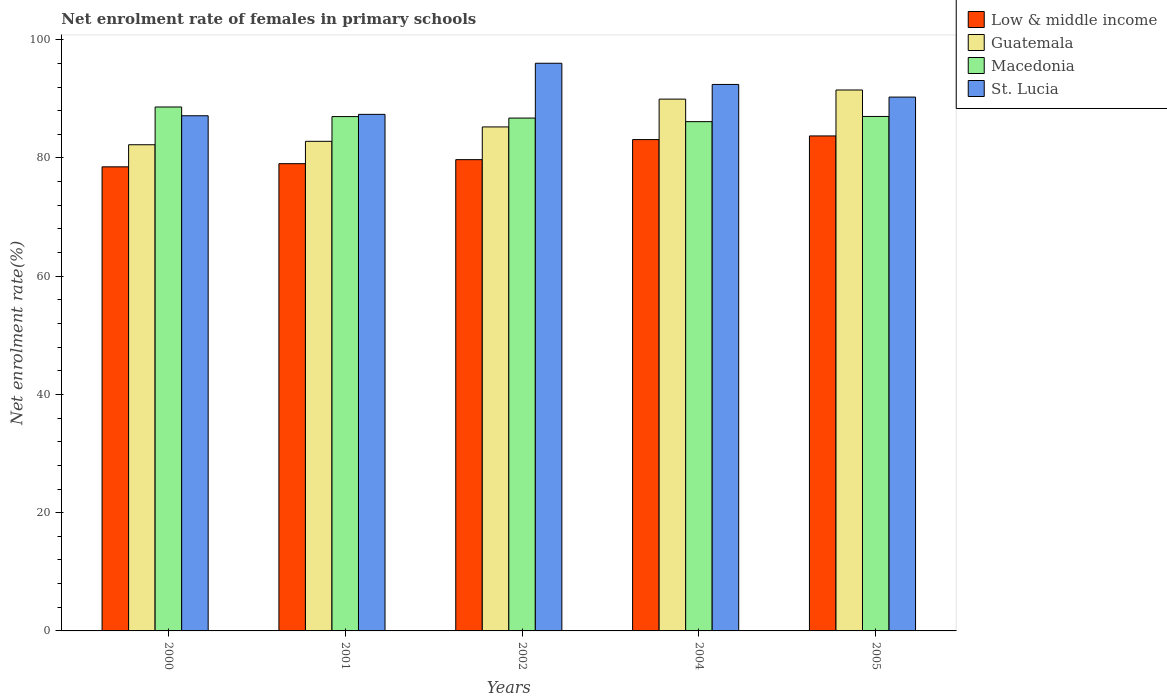How many different coloured bars are there?
Offer a very short reply. 4. How many groups of bars are there?
Your response must be concise. 5. Are the number of bars per tick equal to the number of legend labels?
Offer a terse response. Yes. How many bars are there on the 3rd tick from the left?
Offer a very short reply. 4. In how many cases, is the number of bars for a given year not equal to the number of legend labels?
Provide a short and direct response. 0. What is the net enrolment rate of females in primary schools in Guatemala in 2001?
Your response must be concise. 82.82. Across all years, what is the maximum net enrolment rate of females in primary schools in Guatemala?
Give a very brief answer. 91.5. Across all years, what is the minimum net enrolment rate of females in primary schools in Low & middle income?
Make the answer very short. 78.51. In which year was the net enrolment rate of females in primary schools in St. Lucia maximum?
Your answer should be compact. 2002. What is the total net enrolment rate of females in primary schools in Guatemala in the graph?
Your answer should be very brief. 431.78. What is the difference between the net enrolment rate of females in primary schools in Guatemala in 2000 and that in 2001?
Provide a succinct answer. -0.58. What is the difference between the net enrolment rate of females in primary schools in Low & middle income in 2005 and the net enrolment rate of females in primary schools in St. Lucia in 2004?
Ensure brevity in your answer.  -8.71. What is the average net enrolment rate of females in primary schools in St. Lucia per year?
Offer a terse response. 90.66. In the year 2005, what is the difference between the net enrolment rate of females in primary schools in Guatemala and net enrolment rate of females in primary schools in Low & middle income?
Keep it short and to the point. 7.77. What is the ratio of the net enrolment rate of females in primary schools in Macedonia in 2001 to that in 2005?
Your answer should be compact. 1. Is the net enrolment rate of females in primary schools in Low & middle income in 2002 less than that in 2004?
Give a very brief answer. Yes. What is the difference between the highest and the second highest net enrolment rate of females in primary schools in Low & middle income?
Make the answer very short. 0.62. What is the difference between the highest and the lowest net enrolment rate of females in primary schools in Low & middle income?
Your response must be concise. 5.23. In how many years, is the net enrolment rate of females in primary schools in St. Lucia greater than the average net enrolment rate of females in primary schools in St. Lucia taken over all years?
Your response must be concise. 2. Is the sum of the net enrolment rate of females in primary schools in Guatemala in 2002 and 2004 greater than the maximum net enrolment rate of females in primary schools in St. Lucia across all years?
Make the answer very short. Yes. Is it the case that in every year, the sum of the net enrolment rate of females in primary schools in Guatemala and net enrolment rate of females in primary schools in Macedonia is greater than the sum of net enrolment rate of females in primary schools in Low & middle income and net enrolment rate of females in primary schools in St. Lucia?
Keep it short and to the point. Yes. What does the 3rd bar from the left in 2002 represents?
Give a very brief answer. Macedonia. What does the 2nd bar from the right in 2002 represents?
Offer a terse response. Macedonia. Is it the case that in every year, the sum of the net enrolment rate of females in primary schools in Guatemala and net enrolment rate of females in primary schools in St. Lucia is greater than the net enrolment rate of females in primary schools in Macedonia?
Your answer should be compact. Yes. How many bars are there?
Keep it short and to the point. 20. What is the difference between two consecutive major ticks on the Y-axis?
Your answer should be very brief. 20. Are the values on the major ticks of Y-axis written in scientific E-notation?
Provide a short and direct response. No. Does the graph contain any zero values?
Make the answer very short. No. Does the graph contain grids?
Your answer should be compact. No. How are the legend labels stacked?
Offer a terse response. Vertical. What is the title of the graph?
Offer a very short reply. Net enrolment rate of females in primary schools. What is the label or title of the X-axis?
Keep it short and to the point. Years. What is the label or title of the Y-axis?
Ensure brevity in your answer.  Net enrolment rate(%). What is the Net enrolment rate(%) of Low & middle income in 2000?
Give a very brief answer. 78.51. What is the Net enrolment rate(%) of Guatemala in 2000?
Provide a short and direct response. 82.24. What is the Net enrolment rate(%) of Macedonia in 2000?
Provide a short and direct response. 88.63. What is the Net enrolment rate(%) of St. Lucia in 2000?
Ensure brevity in your answer.  87.15. What is the Net enrolment rate(%) of Low & middle income in 2001?
Offer a very short reply. 79.04. What is the Net enrolment rate(%) in Guatemala in 2001?
Ensure brevity in your answer.  82.82. What is the Net enrolment rate(%) in Macedonia in 2001?
Ensure brevity in your answer.  87.01. What is the Net enrolment rate(%) of St. Lucia in 2001?
Your response must be concise. 87.38. What is the Net enrolment rate(%) in Low & middle income in 2002?
Your response must be concise. 79.72. What is the Net enrolment rate(%) of Guatemala in 2002?
Give a very brief answer. 85.26. What is the Net enrolment rate(%) of Macedonia in 2002?
Make the answer very short. 86.75. What is the Net enrolment rate(%) of St. Lucia in 2002?
Provide a succinct answer. 96.03. What is the Net enrolment rate(%) in Low & middle income in 2004?
Give a very brief answer. 83.11. What is the Net enrolment rate(%) of Guatemala in 2004?
Offer a terse response. 89.96. What is the Net enrolment rate(%) in Macedonia in 2004?
Provide a succinct answer. 86.15. What is the Net enrolment rate(%) in St. Lucia in 2004?
Give a very brief answer. 92.44. What is the Net enrolment rate(%) of Low & middle income in 2005?
Offer a terse response. 83.73. What is the Net enrolment rate(%) in Guatemala in 2005?
Your answer should be very brief. 91.5. What is the Net enrolment rate(%) of Macedonia in 2005?
Offer a very short reply. 87.03. What is the Net enrolment rate(%) in St. Lucia in 2005?
Your answer should be compact. 90.3. Across all years, what is the maximum Net enrolment rate(%) of Low & middle income?
Offer a terse response. 83.73. Across all years, what is the maximum Net enrolment rate(%) of Guatemala?
Keep it short and to the point. 91.5. Across all years, what is the maximum Net enrolment rate(%) of Macedonia?
Make the answer very short. 88.63. Across all years, what is the maximum Net enrolment rate(%) of St. Lucia?
Your response must be concise. 96.03. Across all years, what is the minimum Net enrolment rate(%) of Low & middle income?
Ensure brevity in your answer.  78.51. Across all years, what is the minimum Net enrolment rate(%) in Guatemala?
Ensure brevity in your answer.  82.24. Across all years, what is the minimum Net enrolment rate(%) of Macedonia?
Make the answer very short. 86.15. Across all years, what is the minimum Net enrolment rate(%) in St. Lucia?
Provide a short and direct response. 87.15. What is the total Net enrolment rate(%) in Low & middle income in the graph?
Ensure brevity in your answer.  404.11. What is the total Net enrolment rate(%) of Guatemala in the graph?
Your response must be concise. 431.78. What is the total Net enrolment rate(%) in Macedonia in the graph?
Your answer should be very brief. 435.56. What is the total Net enrolment rate(%) in St. Lucia in the graph?
Your response must be concise. 453.3. What is the difference between the Net enrolment rate(%) of Low & middle income in 2000 and that in 2001?
Your answer should be compact. -0.53. What is the difference between the Net enrolment rate(%) of Guatemala in 2000 and that in 2001?
Keep it short and to the point. -0.58. What is the difference between the Net enrolment rate(%) in Macedonia in 2000 and that in 2001?
Give a very brief answer. 1.62. What is the difference between the Net enrolment rate(%) of St. Lucia in 2000 and that in 2001?
Your answer should be very brief. -0.24. What is the difference between the Net enrolment rate(%) of Low & middle income in 2000 and that in 2002?
Offer a very short reply. -1.21. What is the difference between the Net enrolment rate(%) in Guatemala in 2000 and that in 2002?
Your answer should be compact. -3.01. What is the difference between the Net enrolment rate(%) of Macedonia in 2000 and that in 2002?
Your response must be concise. 1.87. What is the difference between the Net enrolment rate(%) in St. Lucia in 2000 and that in 2002?
Provide a succinct answer. -8.88. What is the difference between the Net enrolment rate(%) of Low & middle income in 2000 and that in 2004?
Your answer should be very brief. -4.61. What is the difference between the Net enrolment rate(%) in Guatemala in 2000 and that in 2004?
Your response must be concise. -7.72. What is the difference between the Net enrolment rate(%) of Macedonia in 2000 and that in 2004?
Provide a short and direct response. 2.48. What is the difference between the Net enrolment rate(%) in St. Lucia in 2000 and that in 2004?
Ensure brevity in your answer.  -5.29. What is the difference between the Net enrolment rate(%) in Low & middle income in 2000 and that in 2005?
Your answer should be compact. -5.23. What is the difference between the Net enrolment rate(%) of Guatemala in 2000 and that in 2005?
Your answer should be compact. -9.26. What is the difference between the Net enrolment rate(%) of Macedonia in 2000 and that in 2005?
Offer a very short reply. 1.6. What is the difference between the Net enrolment rate(%) in St. Lucia in 2000 and that in 2005?
Your answer should be very brief. -3.16. What is the difference between the Net enrolment rate(%) of Low & middle income in 2001 and that in 2002?
Offer a very short reply. -0.68. What is the difference between the Net enrolment rate(%) of Guatemala in 2001 and that in 2002?
Provide a succinct answer. -2.43. What is the difference between the Net enrolment rate(%) in Macedonia in 2001 and that in 2002?
Your answer should be very brief. 0.25. What is the difference between the Net enrolment rate(%) of St. Lucia in 2001 and that in 2002?
Give a very brief answer. -8.64. What is the difference between the Net enrolment rate(%) in Low & middle income in 2001 and that in 2004?
Your answer should be compact. -4.08. What is the difference between the Net enrolment rate(%) of Guatemala in 2001 and that in 2004?
Provide a succinct answer. -7.14. What is the difference between the Net enrolment rate(%) in Macedonia in 2001 and that in 2004?
Give a very brief answer. 0.86. What is the difference between the Net enrolment rate(%) of St. Lucia in 2001 and that in 2004?
Give a very brief answer. -5.06. What is the difference between the Net enrolment rate(%) in Low & middle income in 2001 and that in 2005?
Keep it short and to the point. -4.69. What is the difference between the Net enrolment rate(%) of Guatemala in 2001 and that in 2005?
Offer a very short reply. -8.68. What is the difference between the Net enrolment rate(%) in Macedonia in 2001 and that in 2005?
Provide a short and direct response. -0.02. What is the difference between the Net enrolment rate(%) in St. Lucia in 2001 and that in 2005?
Ensure brevity in your answer.  -2.92. What is the difference between the Net enrolment rate(%) of Low & middle income in 2002 and that in 2004?
Your answer should be very brief. -3.39. What is the difference between the Net enrolment rate(%) of Guatemala in 2002 and that in 2004?
Make the answer very short. -4.7. What is the difference between the Net enrolment rate(%) in Macedonia in 2002 and that in 2004?
Ensure brevity in your answer.  0.61. What is the difference between the Net enrolment rate(%) of St. Lucia in 2002 and that in 2004?
Give a very brief answer. 3.59. What is the difference between the Net enrolment rate(%) of Low & middle income in 2002 and that in 2005?
Offer a terse response. -4.01. What is the difference between the Net enrolment rate(%) in Guatemala in 2002 and that in 2005?
Your response must be concise. -6.25. What is the difference between the Net enrolment rate(%) of Macedonia in 2002 and that in 2005?
Your response must be concise. -0.27. What is the difference between the Net enrolment rate(%) in St. Lucia in 2002 and that in 2005?
Your answer should be compact. 5.72. What is the difference between the Net enrolment rate(%) in Low & middle income in 2004 and that in 2005?
Your response must be concise. -0.62. What is the difference between the Net enrolment rate(%) of Guatemala in 2004 and that in 2005?
Offer a very short reply. -1.54. What is the difference between the Net enrolment rate(%) of Macedonia in 2004 and that in 2005?
Provide a succinct answer. -0.88. What is the difference between the Net enrolment rate(%) in St. Lucia in 2004 and that in 2005?
Offer a very short reply. 2.14. What is the difference between the Net enrolment rate(%) in Low & middle income in 2000 and the Net enrolment rate(%) in Guatemala in 2001?
Give a very brief answer. -4.32. What is the difference between the Net enrolment rate(%) of Low & middle income in 2000 and the Net enrolment rate(%) of Macedonia in 2001?
Give a very brief answer. -8.5. What is the difference between the Net enrolment rate(%) in Low & middle income in 2000 and the Net enrolment rate(%) in St. Lucia in 2001?
Provide a short and direct response. -8.88. What is the difference between the Net enrolment rate(%) of Guatemala in 2000 and the Net enrolment rate(%) of Macedonia in 2001?
Offer a terse response. -4.76. What is the difference between the Net enrolment rate(%) in Guatemala in 2000 and the Net enrolment rate(%) in St. Lucia in 2001?
Provide a short and direct response. -5.14. What is the difference between the Net enrolment rate(%) in Macedonia in 2000 and the Net enrolment rate(%) in St. Lucia in 2001?
Ensure brevity in your answer.  1.24. What is the difference between the Net enrolment rate(%) of Low & middle income in 2000 and the Net enrolment rate(%) of Guatemala in 2002?
Provide a succinct answer. -6.75. What is the difference between the Net enrolment rate(%) of Low & middle income in 2000 and the Net enrolment rate(%) of Macedonia in 2002?
Your answer should be compact. -8.25. What is the difference between the Net enrolment rate(%) in Low & middle income in 2000 and the Net enrolment rate(%) in St. Lucia in 2002?
Keep it short and to the point. -17.52. What is the difference between the Net enrolment rate(%) in Guatemala in 2000 and the Net enrolment rate(%) in Macedonia in 2002?
Offer a terse response. -4.51. What is the difference between the Net enrolment rate(%) in Guatemala in 2000 and the Net enrolment rate(%) in St. Lucia in 2002?
Ensure brevity in your answer.  -13.78. What is the difference between the Net enrolment rate(%) of Macedonia in 2000 and the Net enrolment rate(%) of St. Lucia in 2002?
Keep it short and to the point. -7.4. What is the difference between the Net enrolment rate(%) of Low & middle income in 2000 and the Net enrolment rate(%) of Guatemala in 2004?
Provide a short and direct response. -11.45. What is the difference between the Net enrolment rate(%) in Low & middle income in 2000 and the Net enrolment rate(%) in Macedonia in 2004?
Make the answer very short. -7.64. What is the difference between the Net enrolment rate(%) of Low & middle income in 2000 and the Net enrolment rate(%) of St. Lucia in 2004?
Your response must be concise. -13.94. What is the difference between the Net enrolment rate(%) of Guatemala in 2000 and the Net enrolment rate(%) of Macedonia in 2004?
Make the answer very short. -3.91. What is the difference between the Net enrolment rate(%) of Guatemala in 2000 and the Net enrolment rate(%) of St. Lucia in 2004?
Make the answer very short. -10.2. What is the difference between the Net enrolment rate(%) of Macedonia in 2000 and the Net enrolment rate(%) of St. Lucia in 2004?
Ensure brevity in your answer.  -3.81. What is the difference between the Net enrolment rate(%) in Low & middle income in 2000 and the Net enrolment rate(%) in Guatemala in 2005?
Keep it short and to the point. -13. What is the difference between the Net enrolment rate(%) in Low & middle income in 2000 and the Net enrolment rate(%) in Macedonia in 2005?
Offer a terse response. -8.52. What is the difference between the Net enrolment rate(%) of Low & middle income in 2000 and the Net enrolment rate(%) of St. Lucia in 2005?
Provide a succinct answer. -11.8. What is the difference between the Net enrolment rate(%) of Guatemala in 2000 and the Net enrolment rate(%) of Macedonia in 2005?
Provide a short and direct response. -4.78. What is the difference between the Net enrolment rate(%) in Guatemala in 2000 and the Net enrolment rate(%) in St. Lucia in 2005?
Ensure brevity in your answer.  -8.06. What is the difference between the Net enrolment rate(%) in Macedonia in 2000 and the Net enrolment rate(%) in St. Lucia in 2005?
Provide a short and direct response. -1.67. What is the difference between the Net enrolment rate(%) of Low & middle income in 2001 and the Net enrolment rate(%) of Guatemala in 2002?
Provide a succinct answer. -6.22. What is the difference between the Net enrolment rate(%) of Low & middle income in 2001 and the Net enrolment rate(%) of Macedonia in 2002?
Offer a very short reply. -7.72. What is the difference between the Net enrolment rate(%) of Low & middle income in 2001 and the Net enrolment rate(%) of St. Lucia in 2002?
Ensure brevity in your answer.  -16.99. What is the difference between the Net enrolment rate(%) of Guatemala in 2001 and the Net enrolment rate(%) of Macedonia in 2002?
Offer a terse response. -3.93. What is the difference between the Net enrolment rate(%) in Guatemala in 2001 and the Net enrolment rate(%) in St. Lucia in 2002?
Make the answer very short. -13.2. What is the difference between the Net enrolment rate(%) of Macedonia in 2001 and the Net enrolment rate(%) of St. Lucia in 2002?
Provide a short and direct response. -9.02. What is the difference between the Net enrolment rate(%) of Low & middle income in 2001 and the Net enrolment rate(%) of Guatemala in 2004?
Provide a short and direct response. -10.92. What is the difference between the Net enrolment rate(%) of Low & middle income in 2001 and the Net enrolment rate(%) of Macedonia in 2004?
Your answer should be compact. -7.11. What is the difference between the Net enrolment rate(%) of Low & middle income in 2001 and the Net enrolment rate(%) of St. Lucia in 2004?
Your answer should be very brief. -13.4. What is the difference between the Net enrolment rate(%) of Guatemala in 2001 and the Net enrolment rate(%) of Macedonia in 2004?
Offer a very short reply. -3.33. What is the difference between the Net enrolment rate(%) in Guatemala in 2001 and the Net enrolment rate(%) in St. Lucia in 2004?
Provide a succinct answer. -9.62. What is the difference between the Net enrolment rate(%) in Macedonia in 2001 and the Net enrolment rate(%) in St. Lucia in 2004?
Ensure brevity in your answer.  -5.44. What is the difference between the Net enrolment rate(%) of Low & middle income in 2001 and the Net enrolment rate(%) of Guatemala in 2005?
Provide a succinct answer. -12.47. What is the difference between the Net enrolment rate(%) of Low & middle income in 2001 and the Net enrolment rate(%) of Macedonia in 2005?
Make the answer very short. -7.99. What is the difference between the Net enrolment rate(%) of Low & middle income in 2001 and the Net enrolment rate(%) of St. Lucia in 2005?
Offer a very short reply. -11.26. What is the difference between the Net enrolment rate(%) in Guatemala in 2001 and the Net enrolment rate(%) in Macedonia in 2005?
Provide a short and direct response. -4.2. What is the difference between the Net enrolment rate(%) in Guatemala in 2001 and the Net enrolment rate(%) in St. Lucia in 2005?
Give a very brief answer. -7.48. What is the difference between the Net enrolment rate(%) in Macedonia in 2001 and the Net enrolment rate(%) in St. Lucia in 2005?
Your answer should be very brief. -3.3. What is the difference between the Net enrolment rate(%) of Low & middle income in 2002 and the Net enrolment rate(%) of Guatemala in 2004?
Give a very brief answer. -10.24. What is the difference between the Net enrolment rate(%) in Low & middle income in 2002 and the Net enrolment rate(%) in Macedonia in 2004?
Offer a terse response. -6.43. What is the difference between the Net enrolment rate(%) in Low & middle income in 2002 and the Net enrolment rate(%) in St. Lucia in 2004?
Provide a succinct answer. -12.72. What is the difference between the Net enrolment rate(%) in Guatemala in 2002 and the Net enrolment rate(%) in Macedonia in 2004?
Offer a very short reply. -0.89. What is the difference between the Net enrolment rate(%) in Guatemala in 2002 and the Net enrolment rate(%) in St. Lucia in 2004?
Ensure brevity in your answer.  -7.19. What is the difference between the Net enrolment rate(%) in Macedonia in 2002 and the Net enrolment rate(%) in St. Lucia in 2004?
Provide a succinct answer. -5.69. What is the difference between the Net enrolment rate(%) of Low & middle income in 2002 and the Net enrolment rate(%) of Guatemala in 2005?
Keep it short and to the point. -11.78. What is the difference between the Net enrolment rate(%) of Low & middle income in 2002 and the Net enrolment rate(%) of Macedonia in 2005?
Keep it short and to the point. -7.31. What is the difference between the Net enrolment rate(%) of Low & middle income in 2002 and the Net enrolment rate(%) of St. Lucia in 2005?
Your answer should be compact. -10.58. What is the difference between the Net enrolment rate(%) in Guatemala in 2002 and the Net enrolment rate(%) in Macedonia in 2005?
Your response must be concise. -1.77. What is the difference between the Net enrolment rate(%) in Guatemala in 2002 and the Net enrolment rate(%) in St. Lucia in 2005?
Provide a succinct answer. -5.05. What is the difference between the Net enrolment rate(%) of Macedonia in 2002 and the Net enrolment rate(%) of St. Lucia in 2005?
Your answer should be compact. -3.55. What is the difference between the Net enrolment rate(%) in Low & middle income in 2004 and the Net enrolment rate(%) in Guatemala in 2005?
Keep it short and to the point. -8.39. What is the difference between the Net enrolment rate(%) in Low & middle income in 2004 and the Net enrolment rate(%) in Macedonia in 2005?
Offer a very short reply. -3.91. What is the difference between the Net enrolment rate(%) in Low & middle income in 2004 and the Net enrolment rate(%) in St. Lucia in 2005?
Keep it short and to the point. -7.19. What is the difference between the Net enrolment rate(%) in Guatemala in 2004 and the Net enrolment rate(%) in Macedonia in 2005?
Keep it short and to the point. 2.93. What is the difference between the Net enrolment rate(%) in Guatemala in 2004 and the Net enrolment rate(%) in St. Lucia in 2005?
Your response must be concise. -0.34. What is the difference between the Net enrolment rate(%) of Macedonia in 2004 and the Net enrolment rate(%) of St. Lucia in 2005?
Offer a very short reply. -4.15. What is the average Net enrolment rate(%) of Low & middle income per year?
Your answer should be very brief. 80.82. What is the average Net enrolment rate(%) of Guatemala per year?
Your answer should be compact. 86.36. What is the average Net enrolment rate(%) in Macedonia per year?
Offer a very short reply. 87.11. What is the average Net enrolment rate(%) of St. Lucia per year?
Your answer should be compact. 90.66. In the year 2000, what is the difference between the Net enrolment rate(%) of Low & middle income and Net enrolment rate(%) of Guatemala?
Your response must be concise. -3.74. In the year 2000, what is the difference between the Net enrolment rate(%) of Low & middle income and Net enrolment rate(%) of Macedonia?
Make the answer very short. -10.12. In the year 2000, what is the difference between the Net enrolment rate(%) of Low & middle income and Net enrolment rate(%) of St. Lucia?
Offer a very short reply. -8.64. In the year 2000, what is the difference between the Net enrolment rate(%) in Guatemala and Net enrolment rate(%) in Macedonia?
Offer a very short reply. -6.39. In the year 2000, what is the difference between the Net enrolment rate(%) in Guatemala and Net enrolment rate(%) in St. Lucia?
Offer a very short reply. -4.9. In the year 2000, what is the difference between the Net enrolment rate(%) of Macedonia and Net enrolment rate(%) of St. Lucia?
Keep it short and to the point. 1.48. In the year 2001, what is the difference between the Net enrolment rate(%) in Low & middle income and Net enrolment rate(%) in Guatemala?
Ensure brevity in your answer.  -3.78. In the year 2001, what is the difference between the Net enrolment rate(%) in Low & middle income and Net enrolment rate(%) in Macedonia?
Keep it short and to the point. -7.97. In the year 2001, what is the difference between the Net enrolment rate(%) of Low & middle income and Net enrolment rate(%) of St. Lucia?
Offer a terse response. -8.35. In the year 2001, what is the difference between the Net enrolment rate(%) of Guatemala and Net enrolment rate(%) of Macedonia?
Offer a very short reply. -4.18. In the year 2001, what is the difference between the Net enrolment rate(%) of Guatemala and Net enrolment rate(%) of St. Lucia?
Your response must be concise. -4.56. In the year 2001, what is the difference between the Net enrolment rate(%) in Macedonia and Net enrolment rate(%) in St. Lucia?
Give a very brief answer. -0.38. In the year 2002, what is the difference between the Net enrolment rate(%) in Low & middle income and Net enrolment rate(%) in Guatemala?
Keep it short and to the point. -5.54. In the year 2002, what is the difference between the Net enrolment rate(%) in Low & middle income and Net enrolment rate(%) in Macedonia?
Offer a very short reply. -7.04. In the year 2002, what is the difference between the Net enrolment rate(%) in Low & middle income and Net enrolment rate(%) in St. Lucia?
Your response must be concise. -16.31. In the year 2002, what is the difference between the Net enrolment rate(%) in Guatemala and Net enrolment rate(%) in Macedonia?
Your response must be concise. -1.5. In the year 2002, what is the difference between the Net enrolment rate(%) of Guatemala and Net enrolment rate(%) of St. Lucia?
Keep it short and to the point. -10.77. In the year 2002, what is the difference between the Net enrolment rate(%) of Macedonia and Net enrolment rate(%) of St. Lucia?
Your answer should be very brief. -9.27. In the year 2004, what is the difference between the Net enrolment rate(%) in Low & middle income and Net enrolment rate(%) in Guatemala?
Your answer should be compact. -6.85. In the year 2004, what is the difference between the Net enrolment rate(%) in Low & middle income and Net enrolment rate(%) in Macedonia?
Ensure brevity in your answer.  -3.03. In the year 2004, what is the difference between the Net enrolment rate(%) of Low & middle income and Net enrolment rate(%) of St. Lucia?
Provide a succinct answer. -9.33. In the year 2004, what is the difference between the Net enrolment rate(%) of Guatemala and Net enrolment rate(%) of Macedonia?
Your answer should be compact. 3.81. In the year 2004, what is the difference between the Net enrolment rate(%) in Guatemala and Net enrolment rate(%) in St. Lucia?
Give a very brief answer. -2.48. In the year 2004, what is the difference between the Net enrolment rate(%) in Macedonia and Net enrolment rate(%) in St. Lucia?
Make the answer very short. -6.29. In the year 2005, what is the difference between the Net enrolment rate(%) in Low & middle income and Net enrolment rate(%) in Guatemala?
Your answer should be compact. -7.77. In the year 2005, what is the difference between the Net enrolment rate(%) of Low & middle income and Net enrolment rate(%) of Macedonia?
Make the answer very short. -3.29. In the year 2005, what is the difference between the Net enrolment rate(%) in Low & middle income and Net enrolment rate(%) in St. Lucia?
Your answer should be compact. -6.57. In the year 2005, what is the difference between the Net enrolment rate(%) of Guatemala and Net enrolment rate(%) of Macedonia?
Offer a terse response. 4.48. In the year 2005, what is the difference between the Net enrolment rate(%) of Guatemala and Net enrolment rate(%) of St. Lucia?
Your answer should be very brief. 1.2. In the year 2005, what is the difference between the Net enrolment rate(%) in Macedonia and Net enrolment rate(%) in St. Lucia?
Your answer should be very brief. -3.28. What is the ratio of the Net enrolment rate(%) in Macedonia in 2000 to that in 2001?
Provide a short and direct response. 1.02. What is the ratio of the Net enrolment rate(%) in Low & middle income in 2000 to that in 2002?
Ensure brevity in your answer.  0.98. What is the ratio of the Net enrolment rate(%) in Guatemala in 2000 to that in 2002?
Make the answer very short. 0.96. What is the ratio of the Net enrolment rate(%) of Macedonia in 2000 to that in 2002?
Make the answer very short. 1.02. What is the ratio of the Net enrolment rate(%) in St. Lucia in 2000 to that in 2002?
Your response must be concise. 0.91. What is the ratio of the Net enrolment rate(%) in Low & middle income in 2000 to that in 2004?
Your answer should be compact. 0.94. What is the ratio of the Net enrolment rate(%) in Guatemala in 2000 to that in 2004?
Offer a terse response. 0.91. What is the ratio of the Net enrolment rate(%) in Macedonia in 2000 to that in 2004?
Give a very brief answer. 1.03. What is the ratio of the Net enrolment rate(%) of St. Lucia in 2000 to that in 2004?
Give a very brief answer. 0.94. What is the ratio of the Net enrolment rate(%) of Low & middle income in 2000 to that in 2005?
Your answer should be very brief. 0.94. What is the ratio of the Net enrolment rate(%) of Guatemala in 2000 to that in 2005?
Offer a terse response. 0.9. What is the ratio of the Net enrolment rate(%) in Macedonia in 2000 to that in 2005?
Your answer should be very brief. 1.02. What is the ratio of the Net enrolment rate(%) in Low & middle income in 2001 to that in 2002?
Ensure brevity in your answer.  0.99. What is the ratio of the Net enrolment rate(%) in Guatemala in 2001 to that in 2002?
Your answer should be compact. 0.97. What is the ratio of the Net enrolment rate(%) in Macedonia in 2001 to that in 2002?
Provide a short and direct response. 1. What is the ratio of the Net enrolment rate(%) in St. Lucia in 2001 to that in 2002?
Your answer should be very brief. 0.91. What is the ratio of the Net enrolment rate(%) in Low & middle income in 2001 to that in 2004?
Your response must be concise. 0.95. What is the ratio of the Net enrolment rate(%) of Guatemala in 2001 to that in 2004?
Your response must be concise. 0.92. What is the ratio of the Net enrolment rate(%) of Macedonia in 2001 to that in 2004?
Your answer should be compact. 1.01. What is the ratio of the Net enrolment rate(%) in St. Lucia in 2001 to that in 2004?
Make the answer very short. 0.95. What is the ratio of the Net enrolment rate(%) in Low & middle income in 2001 to that in 2005?
Provide a short and direct response. 0.94. What is the ratio of the Net enrolment rate(%) in Guatemala in 2001 to that in 2005?
Offer a very short reply. 0.91. What is the ratio of the Net enrolment rate(%) in Macedonia in 2001 to that in 2005?
Your response must be concise. 1. What is the ratio of the Net enrolment rate(%) in Low & middle income in 2002 to that in 2004?
Keep it short and to the point. 0.96. What is the ratio of the Net enrolment rate(%) of Guatemala in 2002 to that in 2004?
Make the answer very short. 0.95. What is the ratio of the Net enrolment rate(%) of Macedonia in 2002 to that in 2004?
Provide a short and direct response. 1.01. What is the ratio of the Net enrolment rate(%) of St. Lucia in 2002 to that in 2004?
Your answer should be compact. 1.04. What is the ratio of the Net enrolment rate(%) in Low & middle income in 2002 to that in 2005?
Offer a terse response. 0.95. What is the ratio of the Net enrolment rate(%) in Guatemala in 2002 to that in 2005?
Offer a terse response. 0.93. What is the ratio of the Net enrolment rate(%) of Macedonia in 2002 to that in 2005?
Provide a short and direct response. 1. What is the ratio of the Net enrolment rate(%) in St. Lucia in 2002 to that in 2005?
Your answer should be very brief. 1.06. What is the ratio of the Net enrolment rate(%) of Guatemala in 2004 to that in 2005?
Ensure brevity in your answer.  0.98. What is the ratio of the Net enrolment rate(%) in St. Lucia in 2004 to that in 2005?
Offer a very short reply. 1.02. What is the difference between the highest and the second highest Net enrolment rate(%) of Low & middle income?
Ensure brevity in your answer.  0.62. What is the difference between the highest and the second highest Net enrolment rate(%) of Guatemala?
Provide a succinct answer. 1.54. What is the difference between the highest and the second highest Net enrolment rate(%) in Macedonia?
Give a very brief answer. 1.6. What is the difference between the highest and the second highest Net enrolment rate(%) of St. Lucia?
Make the answer very short. 3.59. What is the difference between the highest and the lowest Net enrolment rate(%) in Low & middle income?
Keep it short and to the point. 5.23. What is the difference between the highest and the lowest Net enrolment rate(%) of Guatemala?
Your answer should be very brief. 9.26. What is the difference between the highest and the lowest Net enrolment rate(%) of Macedonia?
Your answer should be very brief. 2.48. What is the difference between the highest and the lowest Net enrolment rate(%) in St. Lucia?
Give a very brief answer. 8.88. 